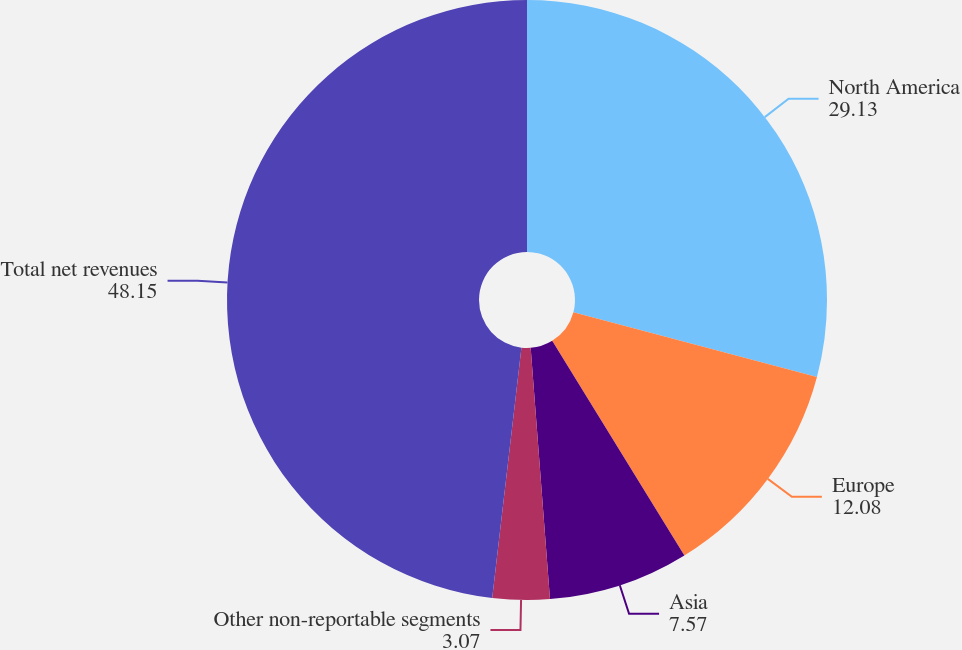<chart> <loc_0><loc_0><loc_500><loc_500><pie_chart><fcel>North America<fcel>Europe<fcel>Asia<fcel>Other non-reportable segments<fcel>Total net revenues<nl><fcel>29.13%<fcel>12.08%<fcel>7.57%<fcel>3.07%<fcel>48.15%<nl></chart> 